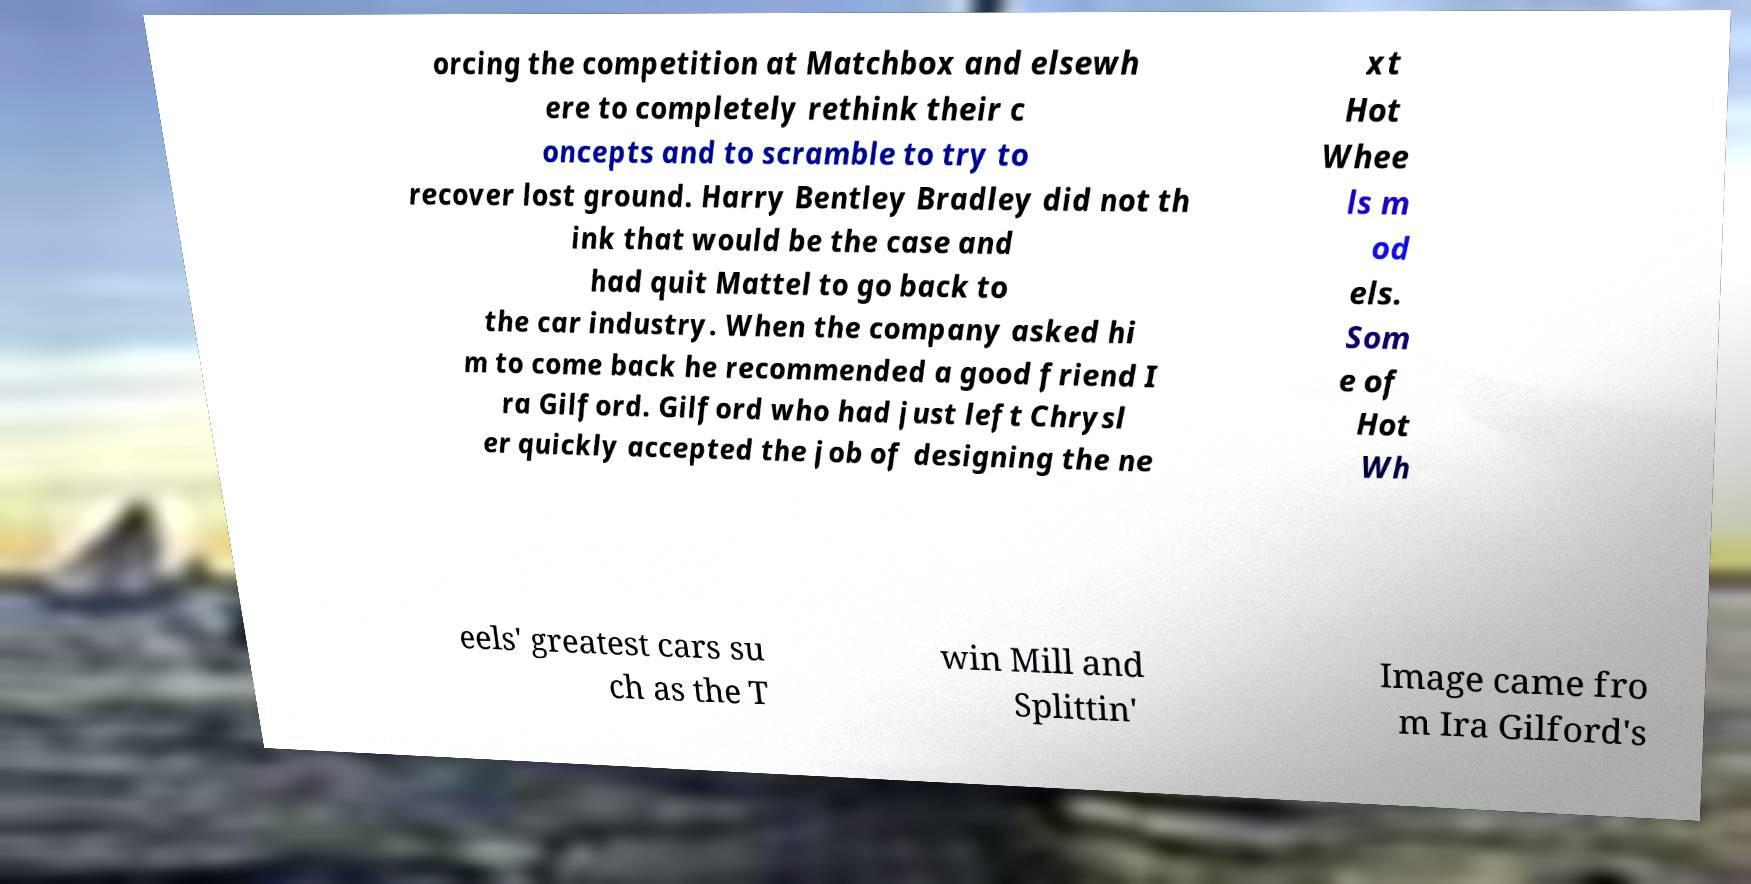Could you assist in decoding the text presented in this image and type it out clearly? orcing the competition at Matchbox and elsewh ere to completely rethink their c oncepts and to scramble to try to recover lost ground. Harry Bentley Bradley did not th ink that would be the case and had quit Mattel to go back to the car industry. When the company asked hi m to come back he recommended a good friend I ra Gilford. Gilford who had just left Chrysl er quickly accepted the job of designing the ne xt Hot Whee ls m od els. Som e of Hot Wh eels' greatest cars su ch as the T win Mill and Splittin' Image came fro m Ira Gilford's 